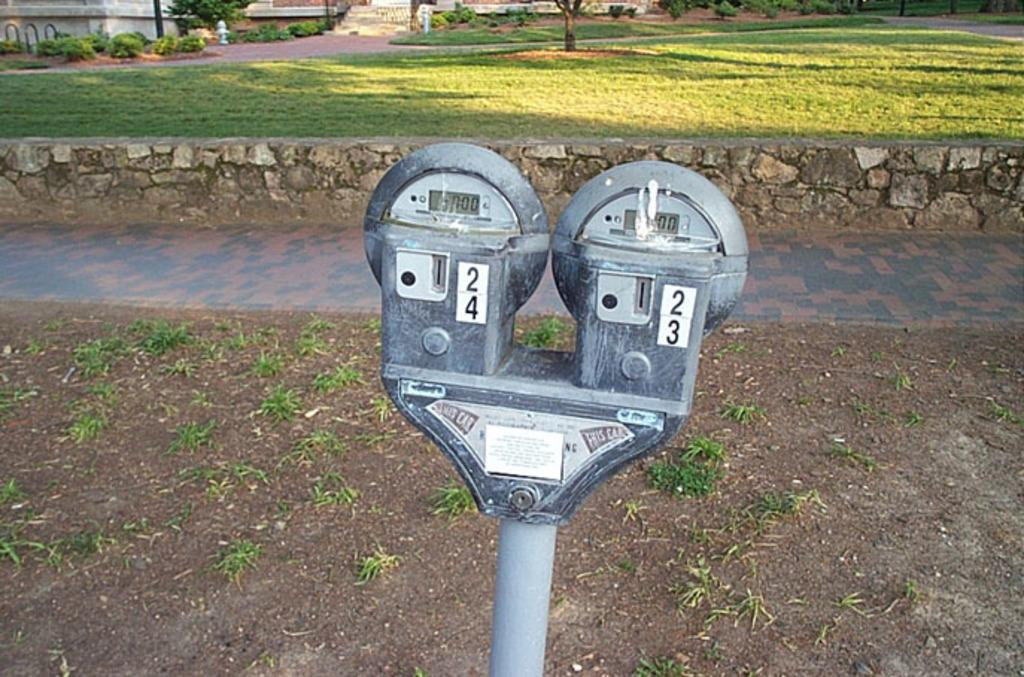<image>
Create a compact narrative representing the image presented. Two parking meters, one that has 24 on it and the other has 23 on it. 